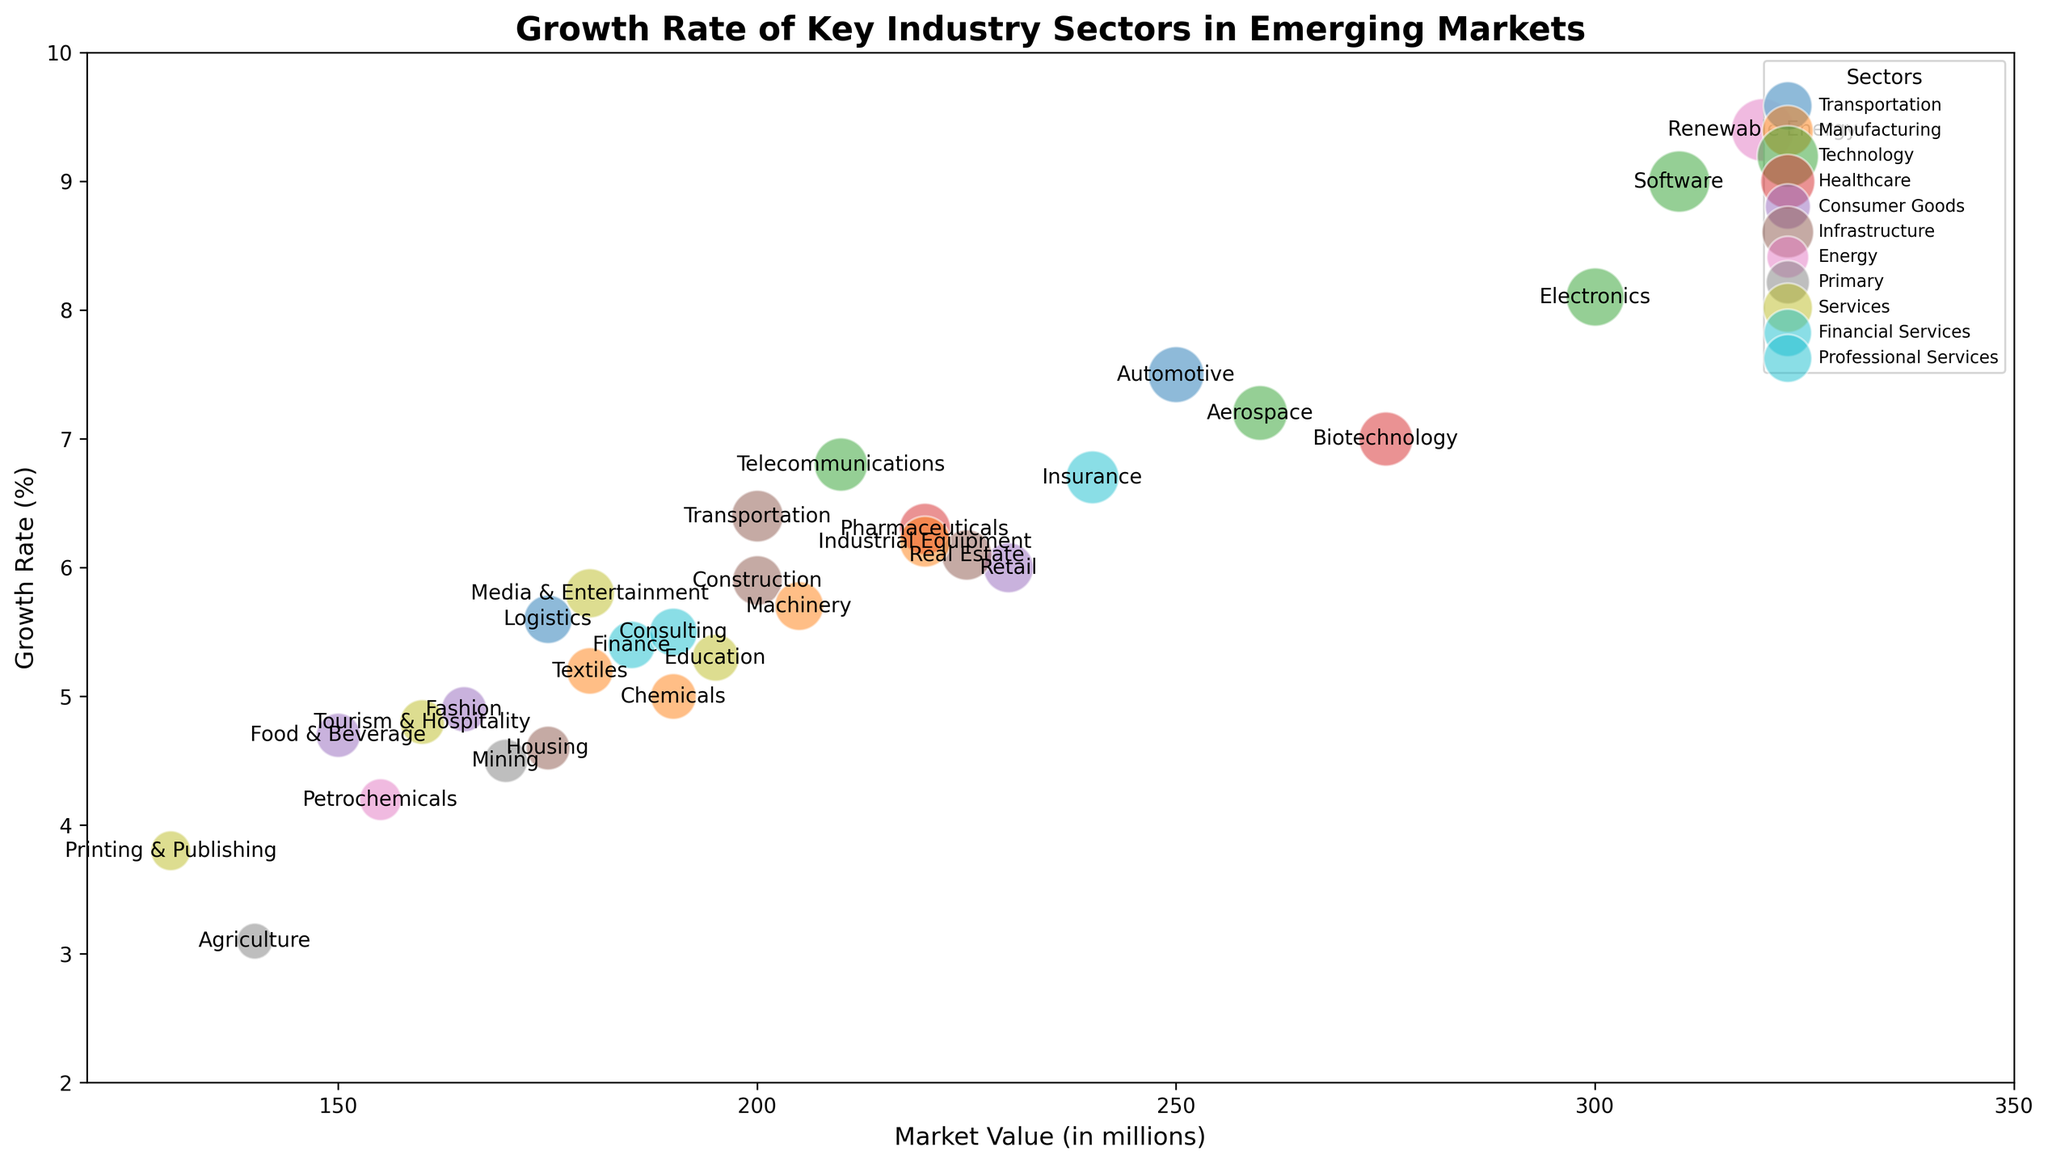What industry has the highest growth rate, and what is the corresponding sector? The industry with the highest growth rate is located at the top of the vertical axis. We see Renewable Energy positioned at the highest point on the chart, which is 9.4%. The corresponding sector is Energy.
Answer: Renewable Energy, Energy Which industry has the smallest market value among those with a growth rate above 7%? First, identify industries with a growth rate above 7%: Automotive, Electronics, Renewable Energy, Aerospace, Biotechnology, and Software. Compare their market values and find that Automotive has a 250 market value, Electronics 300, Renewable Energy 320, Aerospace 260, Biotechnology 275, and Software 310. Automotive has the smallest market value.
Answer: Automotive What is the difference in growth rates between the Electronics and Machinery industries? Locate the growth rates of Electronics and Machinery on the vertical axis. Electronics has a growth rate of 8.1%, and Machinery has a growth rate of 5.7%. The difference is calculated as 8.1 - 5.7.
Answer: 2.4% Which sector has the most number of industries with growth rates above 6%? Identify sectors with industries listed above a 6% growth rate. Transportation (Automotive and Logistics), Technology (Electronics, Telecommunications, Aerospace, Software), Healthcare (Pharmaceuticals, Biotechnology), Financial Services (Insurance), Infrastructure (Real Estate, Transportation). Technology has the most with Electronics, Telecommunications, Aerospace, Software.
Answer: Technology Which industry has a market value of 190 million, and what is its growth rate? Locate the industry labeled closest to the 190 position on the horizontal axis. The Chemicals industry is identified, and its growth rate is 5.0%.
Answer: Chemicals, 5.0% Which industry within the Services sector has the highest market value, and what is its growth rate? Identify industries in the Services sector: Tourism & Hospitality (160), Education (195), Printing & Publishing (130), Media & Entertainment (180). Education has the highest market value at 195 and a growth rate of 5.3%.
Answer: Education, 5.3% Compare the growth rates of the Pharmaceuticals and Software industries. Which one is higher and by how much? Locate the growth rates for Pharmaceuticals and Software. Pharmaceuticals is at 6.3% and Software is at 9.0%. Subtract 6.3 from 9.0 to find the difference. Software is higher by 2.7%.
Answer: Software by 2.7% Which industry has the largest bubble size in the Technology sector, and what are its market value and growth rate? Identify the bubble sizes (Digital Filter by Color) in the Technology sector: Electronics (81), Telecommunications (68), Aerospace (72), Software (90). Software has the largest bubble size. Its market value is 310, and its growth rate is 9.0%.
Answer: Software, 310, 9.0% What is the average growth rate of all industries in the Healthcare sector? Locate the growth rates for Pharmaceuticals (6.3%) and Biotechnology (7.0%). Calculate the average of these two numbers: (6.3 + 7.0) / 2 = 6.65%.
Answer: 6.65% Compare the bubble sizes of the Food & Beverage and Insurance industries and identify which is larger. Identify the bubble sizes for Food & Beverage (47) and Insurance (67). Compare the two values to see which is higher. Insurance has the larger bubble size.
Answer: Insurance 